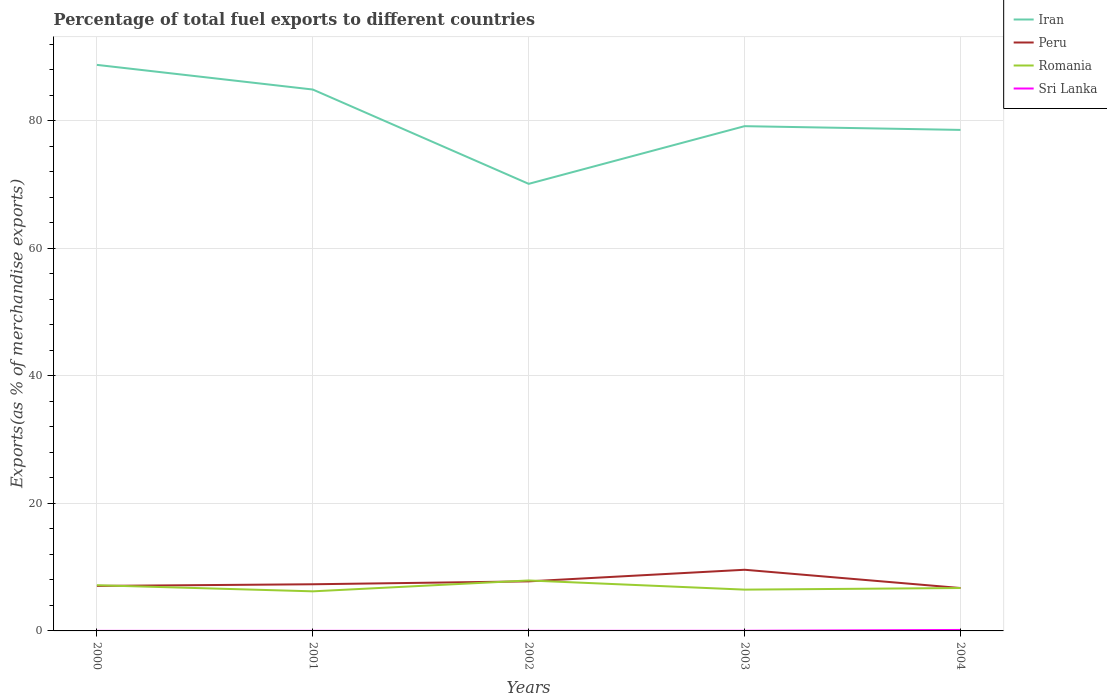How many different coloured lines are there?
Ensure brevity in your answer.  4. Is the number of lines equal to the number of legend labels?
Your answer should be compact. Yes. Across all years, what is the maximum percentage of exports to different countries in Iran?
Provide a short and direct response. 70.09. What is the total percentage of exports to different countries in Iran in the graph?
Your response must be concise. -8.46. What is the difference between the highest and the second highest percentage of exports to different countries in Romania?
Provide a short and direct response. 1.7. Is the percentage of exports to different countries in Sri Lanka strictly greater than the percentage of exports to different countries in Iran over the years?
Give a very brief answer. Yes. How many lines are there?
Your response must be concise. 4. How many years are there in the graph?
Keep it short and to the point. 5. What is the difference between two consecutive major ticks on the Y-axis?
Keep it short and to the point. 20. Does the graph contain grids?
Keep it short and to the point. Yes. Where does the legend appear in the graph?
Your answer should be compact. Top right. How many legend labels are there?
Offer a very short reply. 4. What is the title of the graph?
Offer a terse response. Percentage of total fuel exports to different countries. Does "Morocco" appear as one of the legend labels in the graph?
Give a very brief answer. No. What is the label or title of the Y-axis?
Ensure brevity in your answer.  Exports(as % of merchandise exports). What is the Exports(as % of merchandise exports) in Iran in 2000?
Give a very brief answer. 88.74. What is the Exports(as % of merchandise exports) of Peru in 2000?
Your response must be concise. 7.06. What is the Exports(as % of merchandise exports) of Romania in 2000?
Make the answer very short. 7.16. What is the Exports(as % of merchandise exports) of Sri Lanka in 2000?
Provide a short and direct response. 0.01. What is the Exports(as % of merchandise exports) in Iran in 2001?
Offer a very short reply. 84.88. What is the Exports(as % of merchandise exports) in Peru in 2001?
Your response must be concise. 7.32. What is the Exports(as % of merchandise exports) in Romania in 2001?
Offer a terse response. 6.21. What is the Exports(as % of merchandise exports) of Sri Lanka in 2001?
Offer a very short reply. 0.01. What is the Exports(as % of merchandise exports) in Iran in 2002?
Keep it short and to the point. 70.09. What is the Exports(as % of merchandise exports) of Peru in 2002?
Give a very brief answer. 7.77. What is the Exports(as % of merchandise exports) of Romania in 2002?
Offer a very short reply. 7.91. What is the Exports(as % of merchandise exports) in Sri Lanka in 2002?
Your answer should be compact. 0.01. What is the Exports(as % of merchandise exports) of Iran in 2003?
Offer a very short reply. 79.13. What is the Exports(as % of merchandise exports) of Peru in 2003?
Your response must be concise. 9.59. What is the Exports(as % of merchandise exports) of Romania in 2003?
Make the answer very short. 6.47. What is the Exports(as % of merchandise exports) of Sri Lanka in 2003?
Offer a very short reply. 0.02. What is the Exports(as % of merchandise exports) in Iran in 2004?
Your response must be concise. 78.55. What is the Exports(as % of merchandise exports) of Peru in 2004?
Your response must be concise. 6.72. What is the Exports(as % of merchandise exports) in Romania in 2004?
Your answer should be very brief. 6.73. What is the Exports(as % of merchandise exports) of Sri Lanka in 2004?
Provide a succinct answer. 0.15. Across all years, what is the maximum Exports(as % of merchandise exports) of Iran?
Ensure brevity in your answer.  88.74. Across all years, what is the maximum Exports(as % of merchandise exports) of Peru?
Your answer should be very brief. 9.59. Across all years, what is the maximum Exports(as % of merchandise exports) of Romania?
Provide a short and direct response. 7.91. Across all years, what is the maximum Exports(as % of merchandise exports) of Sri Lanka?
Provide a succinct answer. 0.15. Across all years, what is the minimum Exports(as % of merchandise exports) of Iran?
Provide a succinct answer. 70.09. Across all years, what is the minimum Exports(as % of merchandise exports) in Peru?
Your answer should be compact. 6.72. Across all years, what is the minimum Exports(as % of merchandise exports) in Romania?
Provide a succinct answer. 6.21. Across all years, what is the minimum Exports(as % of merchandise exports) in Sri Lanka?
Offer a very short reply. 0.01. What is the total Exports(as % of merchandise exports) of Iran in the graph?
Keep it short and to the point. 401.39. What is the total Exports(as % of merchandise exports) of Peru in the graph?
Provide a short and direct response. 38.45. What is the total Exports(as % of merchandise exports) in Romania in the graph?
Offer a terse response. 34.48. What is the total Exports(as % of merchandise exports) in Sri Lanka in the graph?
Ensure brevity in your answer.  0.2. What is the difference between the Exports(as % of merchandise exports) of Iran in 2000 and that in 2001?
Give a very brief answer. 3.86. What is the difference between the Exports(as % of merchandise exports) in Peru in 2000 and that in 2001?
Give a very brief answer. -0.26. What is the difference between the Exports(as % of merchandise exports) of Romania in 2000 and that in 2001?
Keep it short and to the point. 0.96. What is the difference between the Exports(as % of merchandise exports) in Sri Lanka in 2000 and that in 2001?
Offer a very short reply. -0.01. What is the difference between the Exports(as % of merchandise exports) of Iran in 2000 and that in 2002?
Give a very brief answer. 18.65. What is the difference between the Exports(as % of merchandise exports) of Peru in 2000 and that in 2002?
Provide a short and direct response. -0.71. What is the difference between the Exports(as % of merchandise exports) in Romania in 2000 and that in 2002?
Your answer should be very brief. -0.75. What is the difference between the Exports(as % of merchandise exports) in Sri Lanka in 2000 and that in 2002?
Offer a terse response. -0. What is the difference between the Exports(as % of merchandise exports) of Iran in 2000 and that in 2003?
Offer a terse response. 9.61. What is the difference between the Exports(as % of merchandise exports) of Peru in 2000 and that in 2003?
Make the answer very short. -2.53. What is the difference between the Exports(as % of merchandise exports) in Romania in 2000 and that in 2003?
Offer a very short reply. 0.69. What is the difference between the Exports(as % of merchandise exports) in Sri Lanka in 2000 and that in 2003?
Your answer should be compact. -0.01. What is the difference between the Exports(as % of merchandise exports) in Iran in 2000 and that in 2004?
Offer a terse response. 10.2. What is the difference between the Exports(as % of merchandise exports) in Peru in 2000 and that in 2004?
Your answer should be very brief. 0.33. What is the difference between the Exports(as % of merchandise exports) of Romania in 2000 and that in 2004?
Keep it short and to the point. 0.44. What is the difference between the Exports(as % of merchandise exports) in Sri Lanka in 2000 and that in 2004?
Offer a terse response. -0.14. What is the difference between the Exports(as % of merchandise exports) in Iran in 2001 and that in 2002?
Your answer should be compact. 14.79. What is the difference between the Exports(as % of merchandise exports) of Peru in 2001 and that in 2002?
Provide a succinct answer. -0.45. What is the difference between the Exports(as % of merchandise exports) of Romania in 2001 and that in 2002?
Your response must be concise. -1.7. What is the difference between the Exports(as % of merchandise exports) of Sri Lanka in 2001 and that in 2002?
Ensure brevity in your answer.  0. What is the difference between the Exports(as % of merchandise exports) in Iran in 2001 and that in 2003?
Your response must be concise. 5.74. What is the difference between the Exports(as % of merchandise exports) in Peru in 2001 and that in 2003?
Give a very brief answer. -2.27. What is the difference between the Exports(as % of merchandise exports) in Romania in 2001 and that in 2003?
Your response must be concise. -0.27. What is the difference between the Exports(as % of merchandise exports) in Sri Lanka in 2001 and that in 2003?
Offer a terse response. -0.01. What is the difference between the Exports(as % of merchandise exports) of Iran in 2001 and that in 2004?
Keep it short and to the point. 6.33. What is the difference between the Exports(as % of merchandise exports) in Peru in 2001 and that in 2004?
Provide a short and direct response. 0.59. What is the difference between the Exports(as % of merchandise exports) of Romania in 2001 and that in 2004?
Provide a short and direct response. -0.52. What is the difference between the Exports(as % of merchandise exports) in Sri Lanka in 2001 and that in 2004?
Your answer should be very brief. -0.14. What is the difference between the Exports(as % of merchandise exports) in Iran in 2002 and that in 2003?
Keep it short and to the point. -9.04. What is the difference between the Exports(as % of merchandise exports) of Peru in 2002 and that in 2003?
Provide a short and direct response. -1.82. What is the difference between the Exports(as % of merchandise exports) in Romania in 2002 and that in 2003?
Your answer should be very brief. 1.44. What is the difference between the Exports(as % of merchandise exports) in Sri Lanka in 2002 and that in 2003?
Provide a short and direct response. -0.01. What is the difference between the Exports(as % of merchandise exports) in Iran in 2002 and that in 2004?
Your answer should be compact. -8.46. What is the difference between the Exports(as % of merchandise exports) of Peru in 2002 and that in 2004?
Offer a terse response. 1.04. What is the difference between the Exports(as % of merchandise exports) in Romania in 2002 and that in 2004?
Ensure brevity in your answer.  1.18. What is the difference between the Exports(as % of merchandise exports) in Sri Lanka in 2002 and that in 2004?
Your answer should be compact. -0.14. What is the difference between the Exports(as % of merchandise exports) of Iran in 2003 and that in 2004?
Your answer should be very brief. 0.59. What is the difference between the Exports(as % of merchandise exports) in Peru in 2003 and that in 2004?
Ensure brevity in your answer.  2.86. What is the difference between the Exports(as % of merchandise exports) in Romania in 2003 and that in 2004?
Ensure brevity in your answer.  -0.25. What is the difference between the Exports(as % of merchandise exports) in Sri Lanka in 2003 and that in 2004?
Your response must be concise. -0.13. What is the difference between the Exports(as % of merchandise exports) in Iran in 2000 and the Exports(as % of merchandise exports) in Peru in 2001?
Offer a very short reply. 81.43. What is the difference between the Exports(as % of merchandise exports) in Iran in 2000 and the Exports(as % of merchandise exports) in Romania in 2001?
Your answer should be very brief. 82.54. What is the difference between the Exports(as % of merchandise exports) in Iran in 2000 and the Exports(as % of merchandise exports) in Sri Lanka in 2001?
Your response must be concise. 88.73. What is the difference between the Exports(as % of merchandise exports) of Peru in 2000 and the Exports(as % of merchandise exports) of Romania in 2001?
Ensure brevity in your answer.  0.85. What is the difference between the Exports(as % of merchandise exports) of Peru in 2000 and the Exports(as % of merchandise exports) of Sri Lanka in 2001?
Keep it short and to the point. 7.04. What is the difference between the Exports(as % of merchandise exports) of Romania in 2000 and the Exports(as % of merchandise exports) of Sri Lanka in 2001?
Your response must be concise. 7.15. What is the difference between the Exports(as % of merchandise exports) of Iran in 2000 and the Exports(as % of merchandise exports) of Peru in 2002?
Ensure brevity in your answer.  80.97. What is the difference between the Exports(as % of merchandise exports) in Iran in 2000 and the Exports(as % of merchandise exports) in Romania in 2002?
Your answer should be compact. 80.83. What is the difference between the Exports(as % of merchandise exports) in Iran in 2000 and the Exports(as % of merchandise exports) in Sri Lanka in 2002?
Offer a terse response. 88.73. What is the difference between the Exports(as % of merchandise exports) in Peru in 2000 and the Exports(as % of merchandise exports) in Romania in 2002?
Your response must be concise. -0.85. What is the difference between the Exports(as % of merchandise exports) of Peru in 2000 and the Exports(as % of merchandise exports) of Sri Lanka in 2002?
Provide a succinct answer. 7.04. What is the difference between the Exports(as % of merchandise exports) in Romania in 2000 and the Exports(as % of merchandise exports) in Sri Lanka in 2002?
Your answer should be compact. 7.15. What is the difference between the Exports(as % of merchandise exports) of Iran in 2000 and the Exports(as % of merchandise exports) of Peru in 2003?
Your answer should be very brief. 79.15. What is the difference between the Exports(as % of merchandise exports) in Iran in 2000 and the Exports(as % of merchandise exports) in Romania in 2003?
Ensure brevity in your answer.  82.27. What is the difference between the Exports(as % of merchandise exports) in Iran in 2000 and the Exports(as % of merchandise exports) in Sri Lanka in 2003?
Keep it short and to the point. 88.72. What is the difference between the Exports(as % of merchandise exports) in Peru in 2000 and the Exports(as % of merchandise exports) in Romania in 2003?
Provide a short and direct response. 0.58. What is the difference between the Exports(as % of merchandise exports) of Peru in 2000 and the Exports(as % of merchandise exports) of Sri Lanka in 2003?
Offer a terse response. 7.04. What is the difference between the Exports(as % of merchandise exports) in Romania in 2000 and the Exports(as % of merchandise exports) in Sri Lanka in 2003?
Ensure brevity in your answer.  7.14. What is the difference between the Exports(as % of merchandise exports) of Iran in 2000 and the Exports(as % of merchandise exports) of Peru in 2004?
Your answer should be compact. 82.02. What is the difference between the Exports(as % of merchandise exports) in Iran in 2000 and the Exports(as % of merchandise exports) in Romania in 2004?
Make the answer very short. 82.01. What is the difference between the Exports(as % of merchandise exports) in Iran in 2000 and the Exports(as % of merchandise exports) in Sri Lanka in 2004?
Ensure brevity in your answer.  88.59. What is the difference between the Exports(as % of merchandise exports) in Peru in 2000 and the Exports(as % of merchandise exports) in Romania in 2004?
Provide a succinct answer. 0.33. What is the difference between the Exports(as % of merchandise exports) in Peru in 2000 and the Exports(as % of merchandise exports) in Sri Lanka in 2004?
Your answer should be very brief. 6.9. What is the difference between the Exports(as % of merchandise exports) in Romania in 2000 and the Exports(as % of merchandise exports) in Sri Lanka in 2004?
Provide a short and direct response. 7.01. What is the difference between the Exports(as % of merchandise exports) in Iran in 2001 and the Exports(as % of merchandise exports) in Peru in 2002?
Make the answer very short. 77.11. What is the difference between the Exports(as % of merchandise exports) of Iran in 2001 and the Exports(as % of merchandise exports) of Romania in 2002?
Give a very brief answer. 76.97. What is the difference between the Exports(as % of merchandise exports) in Iran in 2001 and the Exports(as % of merchandise exports) in Sri Lanka in 2002?
Your response must be concise. 84.87. What is the difference between the Exports(as % of merchandise exports) in Peru in 2001 and the Exports(as % of merchandise exports) in Romania in 2002?
Offer a very short reply. -0.59. What is the difference between the Exports(as % of merchandise exports) in Peru in 2001 and the Exports(as % of merchandise exports) in Sri Lanka in 2002?
Your answer should be compact. 7.31. What is the difference between the Exports(as % of merchandise exports) of Romania in 2001 and the Exports(as % of merchandise exports) of Sri Lanka in 2002?
Ensure brevity in your answer.  6.2. What is the difference between the Exports(as % of merchandise exports) of Iran in 2001 and the Exports(as % of merchandise exports) of Peru in 2003?
Provide a short and direct response. 75.29. What is the difference between the Exports(as % of merchandise exports) in Iran in 2001 and the Exports(as % of merchandise exports) in Romania in 2003?
Keep it short and to the point. 78.4. What is the difference between the Exports(as % of merchandise exports) in Iran in 2001 and the Exports(as % of merchandise exports) in Sri Lanka in 2003?
Keep it short and to the point. 84.86. What is the difference between the Exports(as % of merchandise exports) of Peru in 2001 and the Exports(as % of merchandise exports) of Romania in 2003?
Give a very brief answer. 0.84. What is the difference between the Exports(as % of merchandise exports) in Peru in 2001 and the Exports(as % of merchandise exports) in Sri Lanka in 2003?
Offer a very short reply. 7.3. What is the difference between the Exports(as % of merchandise exports) of Romania in 2001 and the Exports(as % of merchandise exports) of Sri Lanka in 2003?
Make the answer very short. 6.19. What is the difference between the Exports(as % of merchandise exports) of Iran in 2001 and the Exports(as % of merchandise exports) of Peru in 2004?
Your answer should be very brief. 78.15. What is the difference between the Exports(as % of merchandise exports) in Iran in 2001 and the Exports(as % of merchandise exports) in Romania in 2004?
Give a very brief answer. 78.15. What is the difference between the Exports(as % of merchandise exports) of Iran in 2001 and the Exports(as % of merchandise exports) of Sri Lanka in 2004?
Keep it short and to the point. 84.73. What is the difference between the Exports(as % of merchandise exports) of Peru in 2001 and the Exports(as % of merchandise exports) of Romania in 2004?
Give a very brief answer. 0.59. What is the difference between the Exports(as % of merchandise exports) in Peru in 2001 and the Exports(as % of merchandise exports) in Sri Lanka in 2004?
Give a very brief answer. 7.17. What is the difference between the Exports(as % of merchandise exports) in Romania in 2001 and the Exports(as % of merchandise exports) in Sri Lanka in 2004?
Give a very brief answer. 6.06. What is the difference between the Exports(as % of merchandise exports) in Iran in 2002 and the Exports(as % of merchandise exports) in Peru in 2003?
Provide a succinct answer. 60.5. What is the difference between the Exports(as % of merchandise exports) in Iran in 2002 and the Exports(as % of merchandise exports) in Romania in 2003?
Offer a very short reply. 63.62. What is the difference between the Exports(as % of merchandise exports) of Iran in 2002 and the Exports(as % of merchandise exports) of Sri Lanka in 2003?
Make the answer very short. 70.07. What is the difference between the Exports(as % of merchandise exports) of Peru in 2002 and the Exports(as % of merchandise exports) of Romania in 2003?
Ensure brevity in your answer.  1.3. What is the difference between the Exports(as % of merchandise exports) of Peru in 2002 and the Exports(as % of merchandise exports) of Sri Lanka in 2003?
Your answer should be very brief. 7.75. What is the difference between the Exports(as % of merchandise exports) in Romania in 2002 and the Exports(as % of merchandise exports) in Sri Lanka in 2003?
Offer a terse response. 7.89. What is the difference between the Exports(as % of merchandise exports) in Iran in 2002 and the Exports(as % of merchandise exports) in Peru in 2004?
Your answer should be compact. 63.37. What is the difference between the Exports(as % of merchandise exports) in Iran in 2002 and the Exports(as % of merchandise exports) in Romania in 2004?
Provide a succinct answer. 63.36. What is the difference between the Exports(as % of merchandise exports) in Iran in 2002 and the Exports(as % of merchandise exports) in Sri Lanka in 2004?
Offer a very short reply. 69.94. What is the difference between the Exports(as % of merchandise exports) of Peru in 2002 and the Exports(as % of merchandise exports) of Romania in 2004?
Give a very brief answer. 1.04. What is the difference between the Exports(as % of merchandise exports) of Peru in 2002 and the Exports(as % of merchandise exports) of Sri Lanka in 2004?
Ensure brevity in your answer.  7.62. What is the difference between the Exports(as % of merchandise exports) in Romania in 2002 and the Exports(as % of merchandise exports) in Sri Lanka in 2004?
Your answer should be very brief. 7.76. What is the difference between the Exports(as % of merchandise exports) of Iran in 2003 and the Exports(as % of merchandise exports) of Peru in 2004?
Provide a succinct answer. 72.41. What is the difference between the Exports(as % of merchandise exports) in Iran in 2003 and the Exports(as % of merchandise exports) in Romania in 2004?
Provide a succinct answer. 72.41. What is the difference between the Exports(as % of merchandise exports) in Iran in 2003 and the Exports(as % of merchandise exports) in Sri Lanka in 2004?
Offer a very short reply. 78.98. What is the difference between the Exports(as % of merchandise exports) in Peru in 2003 and the Exports(as % of merchandise exports) in Romania in 2004?
Offer a very short reply. 2.86. What is the difference between the Exports(as % of merchandise exports) of Peru in 2003 and the Exports(as % of merchandise exports) of Sri Lanka in 2004?
Offer a very short reply. 9.44. What is the difference between the Exports(as % of merchandise exports) of Romania in 2003 and the Exports(as % of merchandise exports) of Sri Lanka in 2004?
Provide a short and direct response. 6.32. What is the average Exports(as % of merchandise exports) of Iran per year?
Your answer should be compact. 80.28. What is the average Exports(as % of merchandise exports) in Peru per year?
Provide a succinct answer. 7.69. What is the average Exports(as % of merchandise exports) of Romania per year?
Ensure brevity in your answer.  6.9. What is the average Exports(as % of merchandise exports) in Sri Lanka per year?
Provide a short and direct response. 0.04. In the year 2000, what is the difference between the Exports(as % of merchandise exports) of Iran and Exports(as % of merchandise exports) of Peru?
Your answer should be very brief. 81.69. In the year 2000, what is the difference between the Exports(as % of merchandise exports) of Iran and Exports(as % of merchandise exports) of Romania?
Offer a very short reply. 81.58. In the year 2000, what is the difference between the Exports(as % of merchandise exports) of Iran and Exports(as % of merchandise exports) of Sri Lanka?
Offer a terse response. 88.74. In the year 2000, what is the difference between the Exports(as % of merchandise exports) of Peru and Exports(as % of merchandise exports) of Romania?
Give a very brief answer. -0.11. In the year 2000, what is the difference between the Exports(as % of merchandise exports) in Peru and Exports(as % of merchandise exports) in Sri Lanka?
Provide a succinct answer. 7.05. In the year 2000, what is the difference between the Exports(as % of merchandise exports) in Romania and Exports(as % of merchandise exports) in Sri Lanka?
Keep it short and to the point. 7.16. In the year 2001, what is the difference between the Exports(as % of merchandise exports) of Iran and Exports(as % of merchandise exports) of Peru?
Your answer should be very brief. 77.56. In the year 2001, what is the difference between the Exports(as % of merchandise exports) of Iran and Exports(as % of merchandise exports) of Romania?
Provide a succinct answer. 78.67. In the year 2001, what is the difference between the Exports(as % of merchandise exports) of Iran and Exports(as % of merchandise exports) of Sri Lanka?
Your answer should be very brief. 84.87. In the year 2001, what is the difference between the Exports(as % of merchandise exports) of Peru and Exports(as % of merchandise exports) of Romania?
Make the answer very short. 1.11. In the year 2001, what is the difference between the Exports(as % of merchandise exports) of Peru and Exports(as % of merchandise exports) of Sri Lanka?
Give a very brief answer. 7.3. In the year 2001, what is the difference between the Exports(as % of merchandise exports) in Romania and Exports(as % of merchandise exports) in Sri Lanka?
Provide a succinct answer. 6.19. In the year 2002, what is the difference between the Exports(as % of merchandise exports) of Iran and Exports(as % of merchandise exports) of Peru?
Make the answer very short. 62.32. In the year 2002, what is the difference between the Exports(as % of merchandise exports) in Iran and Exports(as % of merchandise exports) in Romania?
Your answer should be very brief. 62.18. In the year 2002, what is the difference between the Exports(as % of merchandise exports) of Iran and Exports(as % of merchandise exports) of Sri Lanka?
Give a very brief answer. 70.08. In the year 2002, what is the difference between the Exports(as % of merchandise exports) in Peru and Exports(as % of merchandise exports) in Romania?
Your response must be concise. -0.14. In the year 2002, what is the difference between the Exports(as % of merchandise exports) in Peru and Exports(as % of merchandise exports) in Sri Lanka?
Your answer should be compact. 7.76. In the year 2002, what is the difference between the Exports(as % of merchandise exports) in Romania and Exports(as % of merchandise exports) in Sri Lanka?
Your answer should be compact. 7.9. In the year 2003, what is the difference between the Exports(as % of merchandise exports) of Iran and Exports(as % of merchandise exports) of Peru?
Your response must be concise. 69.54. In the year 2003, what is the difference between the Exports(as % of merchandise exports) in Iran and Exports(as % of merchandise exports) in Romania?
Ensure brevity in your answer.  72.66. In the year 2003, what is the difference between the Exports(as % of merchandise exports) of Iran and Exports(as % of merchandise exports) of Sri Lanka?
Your answer should be very brief. 79.11. In the year 2003, what is the difference between the Exports(as % of merchandise exports) of Peru and Exports(as % of merchandise exports) of Romania?
Your answer should be very brief. 3.11. In the year 2003, what is the difference between the Exports(as % of merchandise exports) in Peru and Exports(as % of merchandise exports) in Sri Lanka?
Provide a short and direct response. 9.57. In the year 2003, what is the difference between the Exports(as % of merchandise exports) in Romania and Exports(as % of merchandise exports) in Sri Lanka?
Your answer should be compact. 6.45. In the year 2004, what is the difference between the Exports(as % of merchandise exports) in Iran and Exports(as % of merchandise exports) in Peru?
Provide a short and direct response. 71.82. In the year 2004, what is the difference between the Exports(as % of merchandise exports) of Iran and Exports(as % of merchandise exports) of Romania?
Provide a short and direct response. 71.82. In the year 2004, what is the difference between the Exports(as % of merchandise exports) of Iran and Exports(as % of merchandise exports) of Sri Lanka?
Your response must be concise. 78.4. In the year 2004, what is the difference between the Exports(as % of merchandise exports) of Peru and Exports(as % of merchandise exports) of Romania?
Your answer should be compact. -0. In the year 2004, what is the difference between the Exports(as % of merchandise exports) of Peru and Exports(as % of merchandise exports) of Sri Lanka?
Your response must be concise. 6.57. In the year 2004, what is the difference between the Exports(as % of merchandise exports) in Romania and Exports(as % of merchandise exports) in Sri Lanka?
Offer a very short reply. 6.58. What is the ratio of the Exports(as % of merchandise exports) in Iran in 2000 to that in 2001?
Ensure brevity in your answer.  1.05. What is the ratio of the Exports(as % of merchandise exports) of Peru in 2000 to that in 2001?
Offer a terse response. 0.96. What is the ratio of the Exports(as % of merchandise exports) in Romania in 2000 to that in 2001?
Your answer should be very brief. 1.15. What is the ratio of the Exports(as % of merchandise exports) of Sri Lanka in 2000 to that in 2001?
Give a very brief answer. 0.55. What is the ratio of the Exports(as % of merchandise exports) of Iran in 2000 to that in 2002?
Your response must be concise. 1.27. What is the ratio of the Exports(as % of merchandise exports) in Peru in 2000 to that in 2002?
Provide a succinct answer. 0.91. What is the ratio of the Exports(as % of merchandise exports) of Romania in 2000 to that in 2002?
Offer a very short reply. 0.91. What is the ratio of the Exports(as % of merchandise exports) in Sri Lanka in 2000 to that in 2002?
Keep it short and to the point. 0.61. What is the ratio of the Exports(as % of merchandise exports) of Iran in 2000 to that in 2003?
Your answer should be very brief. 1.12. What is the ratio of the Exports(as % of merchandise exports) in Peru in 2000 to that in 2003?
Offer a terse response. 0.74. What is the ratio of the Exports(as % of merchandise exports) of Romania in 2000 to that in 2003?
Your answer should be very brief. 1.11. What is the ratio of the Exports(as % of merchandise exports) of Sri Lanka in 2000 to that in 2003?
Offer a terse response. 0.32. What is the ratio of the Exports(as % of merchandise exports) in Iran in 2000 to that in 2004?
Your answer should be compact. 1.13. What is the ratio of the Exports(as % of merchandise exports) of Peru in 2000 to that in 2004?
Make the answer very short. 1.05. What is the ratio of the Exports(as % of merchandise exports) in Romania in 2000 to that in 2004?
Your response must be concise. 1.06. What is the ratio of the Exports(as % of merchandise exports) of Sri Lanka in 2000 to that in 2004?
Offer a very short reply. 0.04. What is the ratio of the Exports(as % of merchandise exports) of Iran in 2001 to that in 2002?
Provide a short and direct response. 1.21. What is the ratio of the Exports(as % of merchandise exports) in Peru in 2001 to that in 2002?
Your answer should be compact. 0.94. What is the ratio of the Exports(as % of merchandise exports) of Romania in 2001 to that in 2002?
Your answer should be compact. 0.78. What is the ratio of the Exports(as % of merchandise exports) in Sri Lanka in 2001 to that in 2002?
Your answer should be compact. 1.12. What is the ratio of the Exports(as % of merchandise exports) in Iran in 2001 to that in 2003?
Ensure brevity in your answer.  1.07. What is the ratio of the Exports(as % of merchandise exports) in Peru in 2001 to that in 2003?
Offer a terse response. 0.76. What is the ratio of the Exports(as % of merchandise exports) in Romania in 2001 to that in 2003?
Offer a terse response. 0.96. What is the ratio of the Exports(as % of merchandise exports) of Sri Lanka in 2001 to that in 2003?
Give a very brief answer. 0.58. What is the ratio of the Exports(as % of merchandise exports) of Iran in 2001 to that in 2004?
Provide a short and direct response. 1.08. What is the ratio of the Exports(as % of merchandise exports) in Peru in 2001 to that in 2004?
Provide a succinct answer. 1.09. What is the ratio of the Exports(as % of merchandise exports) of Romania in 2001 to that in 2004?
Keep it short and to the point. 0.92. What is the ratio of the Exports(as % of merchandise exports) in Sri Lanka in 2001 to that in 2004?
Your answer should be very brief. 0.07. What is the ratio of the Exports(as % of merchandise exports) in Iran in 2002 to that in 2003?
Give a very brief answer. 0.89. What is the ratio of the Exports(as % of merchandise exports) in Peru in 2002 to that in 2003?
Provide a short and direct response. 0.81. What is the ratio of the Exports(as % of merchandise exports) in Romania in 2002 to that in 2003?
Offer a very short reply. 1.22. What is the ratio of the Exports(as % of merchandise exports) of Sri Lanka in 2002 to that in 2003?
Your answer should be compact. 0.52. What is the ratio of the Exports(as % of merchandise exports) of Iran in 2002 to that in 2004?
Give a very brief answer. 0.89. What is the ratio of the Exports(as % of merchandise exports) of Peru in 2002 to that in 2004?
Give a very brief answer. 1.16. What is the ratio of the Exports(as % of merchandise exports) of Romania in 2002 to that in 2004?
Provide a succinct answer. 1.18. What is the ratio of the Exports(as % of merchandise exports) of Sri Lanka in 2002 to that in 2004?
Make the answer very short. 0.07. What is the ratio of the Exports(as % of merchandise exports) in Iran in 2003 to that in 2004?
Your response must be concise. 1.01. What is the ratio of the Exports(as % of merchandise exports) in Peru in 2003 to that in 2004?
Provide a succinct answer. 1.43. What is the ratio of the Exports(as % of merchandise exports) of Romania in 2003 to that in 2004?
Provide a succinct answer. 0.96. What is the ratio of the Exports(as % of merchandise exports) in Sri Lanka in 2003 to that in 2004?
Your answer should be very brief. 0.13. What is the difference between the highest and the second highest Exports(as % of merchandise exports) of Iran?
Offer a terse response. 3.86. What is the difference between the highest and the second highest Exports(as % of merchandise exports) of Peru?
Ensure brevity in your answer.  1.82. What is the difference between the highest and the second highest Exports(as % of merchandise exports) of Romania?
Offer a very short reply. 0.75. What is the difference between the highest and the second highest Exports(as % of merchandise exports) of Sri Lanka?
Offer a terse response. 0.13. What is the difference between the highest and the lowest Exports(as % of merchandise exports) in Iran?
Provide a succinct answer. 18.65. What is the difference between the highest and the lowest Exports(as % of merchandise exports) in Peru?
Your answer should be very brief. 2.86. What is the difference between the highest and the lowest Exports(as % of merchandise exports) in Romania?
Provide a short and direct response. 1.7. What is the difference between the highest and the lowest Exports(as % of merchandise exports) of Sri Lanka?
Offer a terse response. 0.14. 